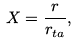Convert formula to latex. <formula><loc_0><loc_0><loc_500><loc_500>X = \frac { r } { r _ { t a } } ,</formula> 